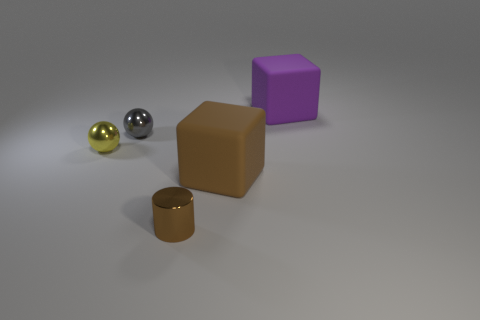Add 2 brown cubes. How many objects exist? 7 Subtract all cylinders. How many objects are left? 4 Add 2 matte cubes. How many matte cubes exist? 4 Subtract 0 purple balls. How many objects are left? 5 Subtract all tiny gray rubber things. Subtract all yellow objects. How many objects are left? 4 Add 2 tiny metallic balls. How many tiny metallic balls are left? 4 